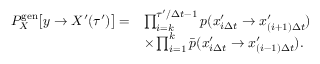Convert formula to latex. <formula><loc_0><loc_0><loc_500><loc_500>\begin{array} { r l } { P _ { X } ^ { g e n } \left [ y \to X ^ { \prime } ( \tau ^ { \prime } ) \right ] = } & { \prod _ { i = k } ^ { \tau ^ { \prime } / \Delta t - 1 } p ( x _ { i \Delta t } ^ { \prime } \to x _ { ( i + 1 ) \Delta t } ^ { \prime } ) } \\ & { \times \prod _ { i = 1 } ^ { k } \bar { p } ( x _ { i \Delta t } ^ { \prime } \to x _ { ( i - 1 ) \Delta t } ^ { \prime } ) . } \end{array}</formula> 